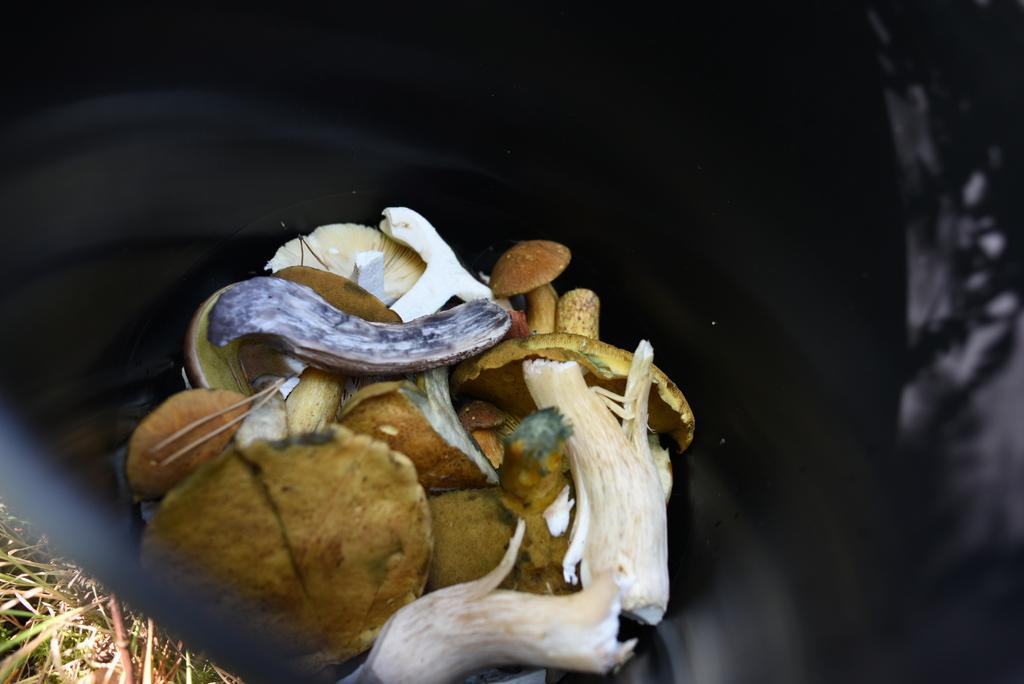Please provide a concise description of this image. In this picture, it seems to be there is a garbage bag in the center of the image, which contains waste materials in it and there is grass in the bottom left side of the image. 